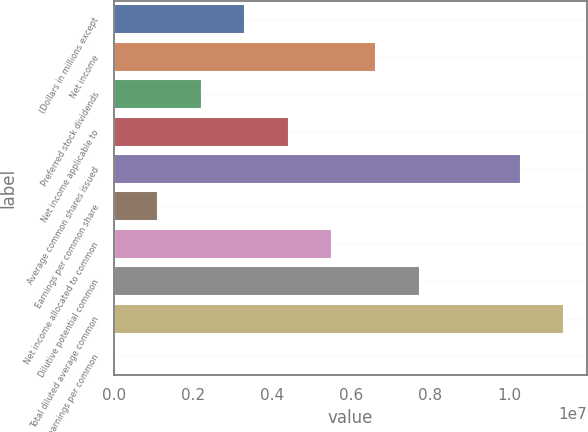Convert chart. <chart><loc_0><loc_0><loc_500><loc_500><bar_chart><fcel>(Dollars in millions except<fcel>Net income<fcel>Preferred stock dividends<fcel>Net income applicable to<fcel>Average common shares issued<fcel>Earnings per common share<fcel>Net income allocated to common<fcel>Dilutive potential common<fcel>Total diluted average common<fcel>Diluted earnings per common<nl><fcel>3.3107e+06<fcel>6.62139e+06<fcel>2.20713e+06<fcel>4.41426e+06<fcel>1.02841e+07<fcel>1.10357e+06<fcel>5.51783e+06<fcel>7.72496e+06<fcel>1.13877e+07<fcel>1.5<nl></chart> 